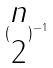<formula> <loc_0><loc_0><loc_500><loc_500>( \begin{matrix} n \\ 2 \end{matrix} ) ^ { - 1 }</formula> 